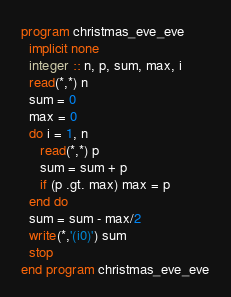Convert code to text. <code><loc_0><loc_0><loc_500><loc_500><_FORTRAN_>program christmas_eve_eve
  implicit none
  integer :: n, p, sum, max, i
  read(*,*) n
  sum = 0
  max = 0
  do i = 1, n
     read(*,*) p
     sum = sum + p
     if (p .gt. max) max = p
  end do
  sum = sum - max/2
  write(*,'(i0)') sum
  stop
end program christmas_eve_eve</code> 